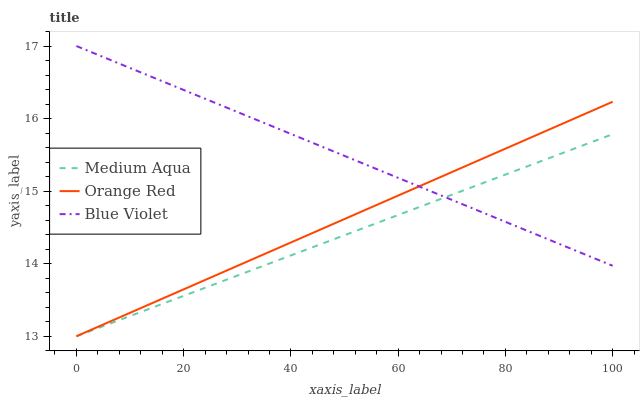Does Medium Aqua have the minimum area under the curve?
Answer yes or no. Yes. Does Blue Violet have the maximum area under the curve?
Answer yes or no. Yes. Does Orange Red have the minimum area under the curve?
Answer yes or no. No. Does Orange Red have the maximum area under the curve?
Answer yes or no. No. Is Orange Red the smoothest?
Answer yes or no. Yes. Is Medium Aqua the roughest?
Answer yes or no. Yes. Is Blue Violet the smoothest?
Answer yes or no. No. Is Blue Violet the roughest?
Answer yes or no. No. Does Medium Aqua have the lowest value?
Answer yes or no. Yes. Does Blue Violet have the lowest value?
Answer yes or no. No. Does Blue Violet have the highest value?
Answer yes or no. Yes. Does Orange Red have the highest value?
Answer yes or no. No. Does Orange Red intersect Medium Aqua?
Answer yes or no. Yes. Is Orange Red less than Medium Aqua?
Answer yes or no. No. Is Orange Red greater than Medium Aqua?
Answer yes or no. No. 